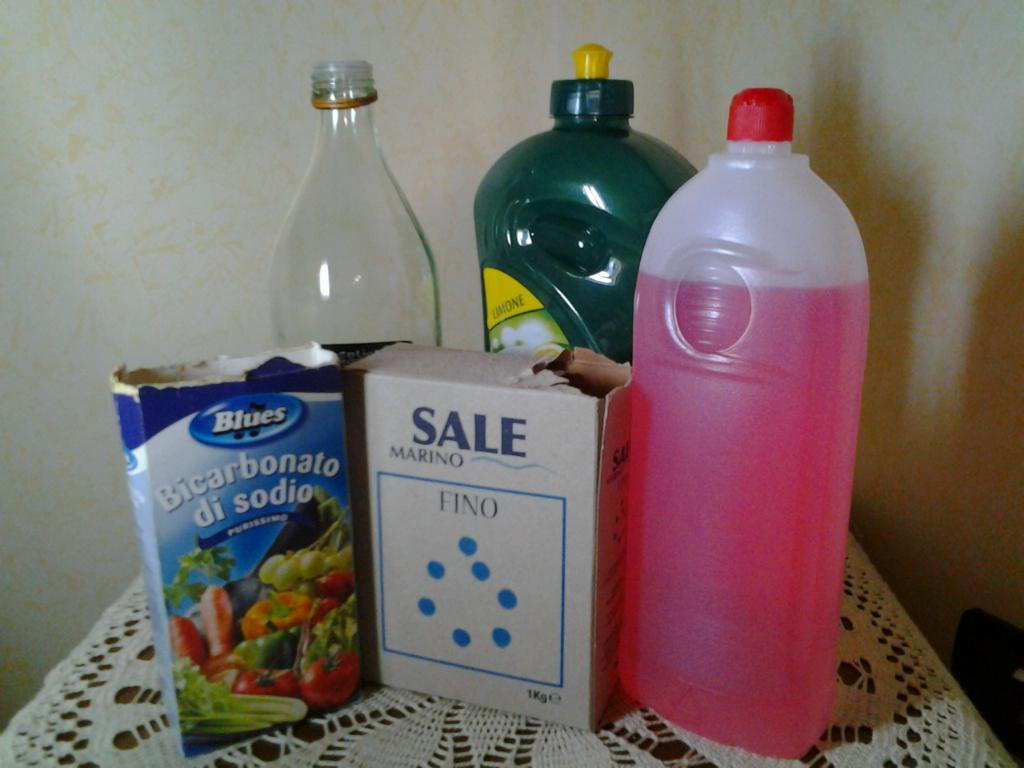<image>
Offer a succinct explanation of the picture presented. A box that says Sale Marino Fino sits with some other containers on a lace tablecloth. 